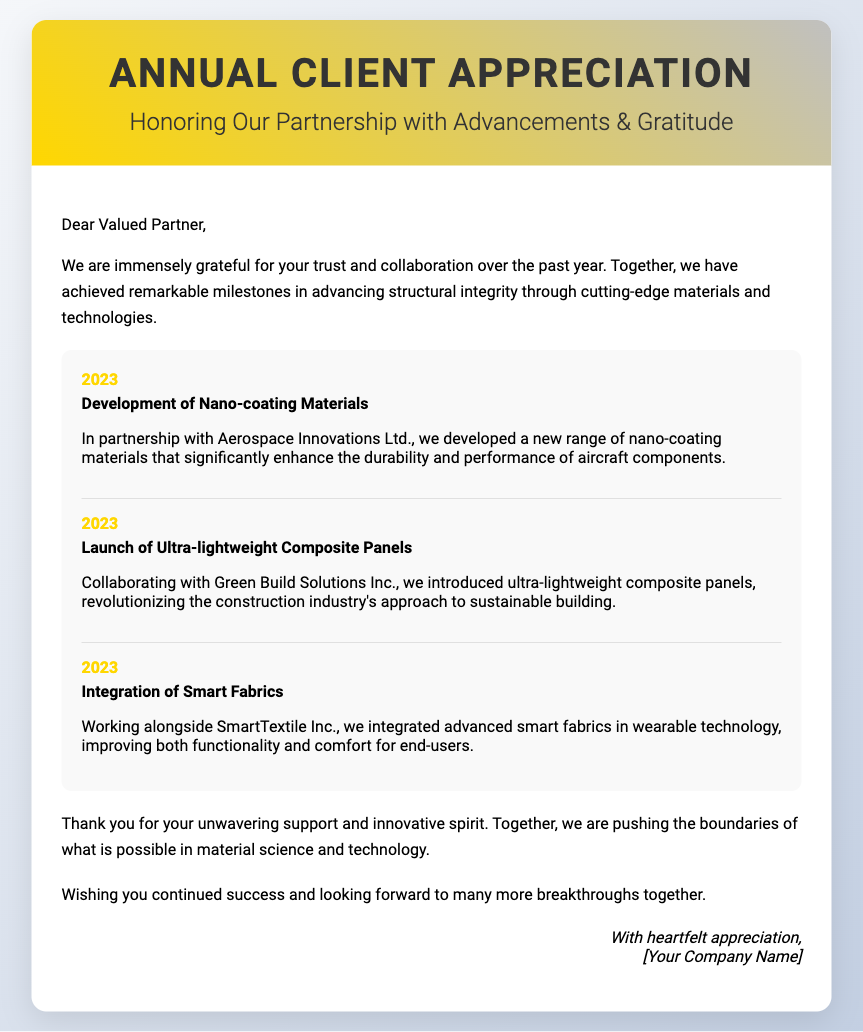What is the title of the card? The title of the card is displayed prominently in the cover section of the document.
Answer: Annual Client Appreciation Who is the card addressed to? The card is addressed to a specific recipient mentioned in the introductory section.
Answer: Valued Partner Which company partnered to develop nano-coating materials? The document specifies the collaborating company in the achievement description for nano-coating materials.
Answer: Aerospace Innovations Ltd What year are all the milestones from? The milestones listed in the card all reference a specific year.
Answer: 2023 What type of panels were launched in collaboration with Green Build Solutions Inc.? The document explicitly details the innovation achieved through this collaboration.
Answer: Ultra-lightweight Composite Panels What is the main theme of the card? The theme is conveyed through the introductory and closing remarks of the card.
Answer: Appreciation and Gratitude Which type of technology was improved with Smart Fabrics? The document outlines the specific application of the smart fabrics in a particular technology sector.
Answer: Wearable technology How does the sender express their gratitude? The sender's expression of gratitude is evident in the gratitude section of the card.
Answer: Unwavering support and innovative spirit What is the closing wish mentioned in the card? The closing section conveys a future-oriented sentiment.
Answer: Continued success 